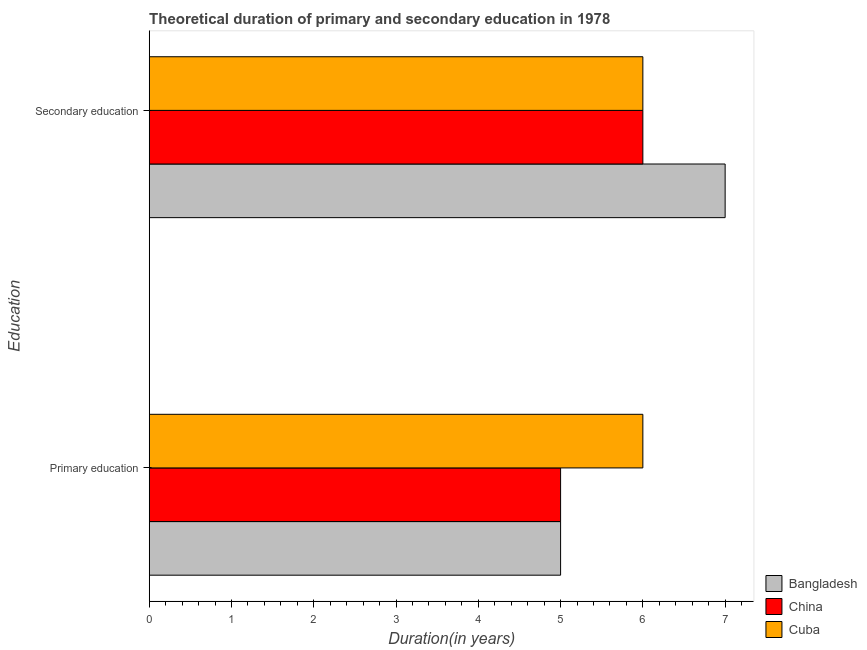How many groups of bars are there?
Offer a terse response. 2. Are the number of bars on each tick of the Y-axis equal?
Your answer should be very brief. Yes. How many bars are there on the 1st tick from the bottom?
Ensure brevity in your answer.  3. What is the duration of secondary education in Bangladesh?
Make the answer very short. 7. Across all countries, what is the maximum duration of secondary education?
Offer a very short reply. 7. Across all countries, what is the minimum duration of secondary education?
Make the answer very short. 6. In which country was the duration of secondary education maximum?
Ensure brevity in your answer.  Bangladesh. What is the total duration of secondary education in the graph?
Provide a short and direct response. 19. What is the difference between the duration of primary education in Cuba and that in Bangladesh?
Provide a short and direct response. 1. What is the difference between the duration of primary education in Bangladesh and the duration of secondary education in Cuba?
Provide a succinct answer. -1. What is the average duration of secondary education per country?
Offer a terse response. 6.33. In how many countries, is the duration of secondary education greater than 0.4 years?
Provide a succinct answer. 3. What is the ratio of the duration of secondary education in Cuba to that in Bangladesh?
Provide a short and direct response. 0.86. What does the 1st bar from the bottom in Primary education represents?
Your answer should be compact. Bangladesh. How many bars are there?
Your answer should be very brief. 6. Are all the bars in the graph horizontal?
Provide a short and direct response. Yes. How many countries are there in the graph?
Provide a succinct answer. 3. What is the difference between two consecutive major ticks on the X-axis?
Keep it short and to the point. 1. Does the graph contain any zero values?
Provide a short and direct response. No. Does the graph contain grids?
Your answer should be very brief. No. Where does the legend appear in the graph?
Offer a very short reply. Bottom right. What is the title of the graph?
Your answer should be very brief. Theoretical duration of primary and secondary education in 1978. What is the label or title of the X-axis?
Ensure brevity in your answer.  Duration(in years). What is the label or title of the Y-axis?
Give a very brief answer. Education. What is the Duration(in years) of Bangladesh in Primary education?
Provide a succinct answer. 5. What is the Duration(in years) in China in Primary education?
Give a very brief answer. 5. What is the Duration(in years) in Cuba in Primary education?
Offer a terse response. 6. What is the Duration(in years) in Bangladesh in Secondary education?
Ensure brevity in your answer.  7. What is the Duration(in years) in Cuba in Secondary education?
Keep it short and to the point. 6. Across all Education, what is the maximum Duration(in years) in Bangladesh?
Your response must be concise. 7. Across all Education, what is the minimum Duration(in years) in Bangladesh?
Ensure brevity in your answer.  5. Across all Education, what is the minimum Duration(in years) of China?
Your answer should be compact. 5. Across all Education, what is the minimum Duration(in years) in Cuba?
Your answer should be compact. 6. What is the total Duration(in years) in China in the graph?
Provide a succinct answer. 11. What is the difference between the Duration(in years) of China in Primary education and that in Secondary education?
Give a very brief answer. -1. What is the difference between the Duration(in years) in Bangladesh in Primary education and the Duration(in years) in China in Secondary education?
Offer a very short reply. -1. What is the average Duration(in years) of China per Education?
Your answer should be compact. 5.5. What is the difference between the Duration(in years) in China and Duration(in years) in Cuba in Primary education?
Provide a succinct answer. -1. What is the difference between the Duration(in years) of Bangladesh and Duration(in years) of Cuba in Secondary education?
Make the answer very short. 1. What is the difference between the Duration(in years) of China and Duration(in years) of Cuba in Secondary education?
Provide a succinct answer. 0. What is the ratio of the Duration(in years) of Cuba in Primary education to that in Secondary education?
Keep it short and to the point. 1. What is the difference between the highest and the second highest Duration(in years) of China?
Provide a succinct answer. 1. What is the difference between the highest and the second highest Duration(in years) of Cuba?
Your response must be concise. 0. What is the difference between the highest and the lowest Duration(in years) of Bangladesh?
Offer a terse response. 2. What is the difference between the highest and the lowest Duration(in years) of China?
Keep it short and to the point. 1. What is the difference between the highest and the lowest Duration(in years) in Cuba?
Your answer should be very brief. 0. 